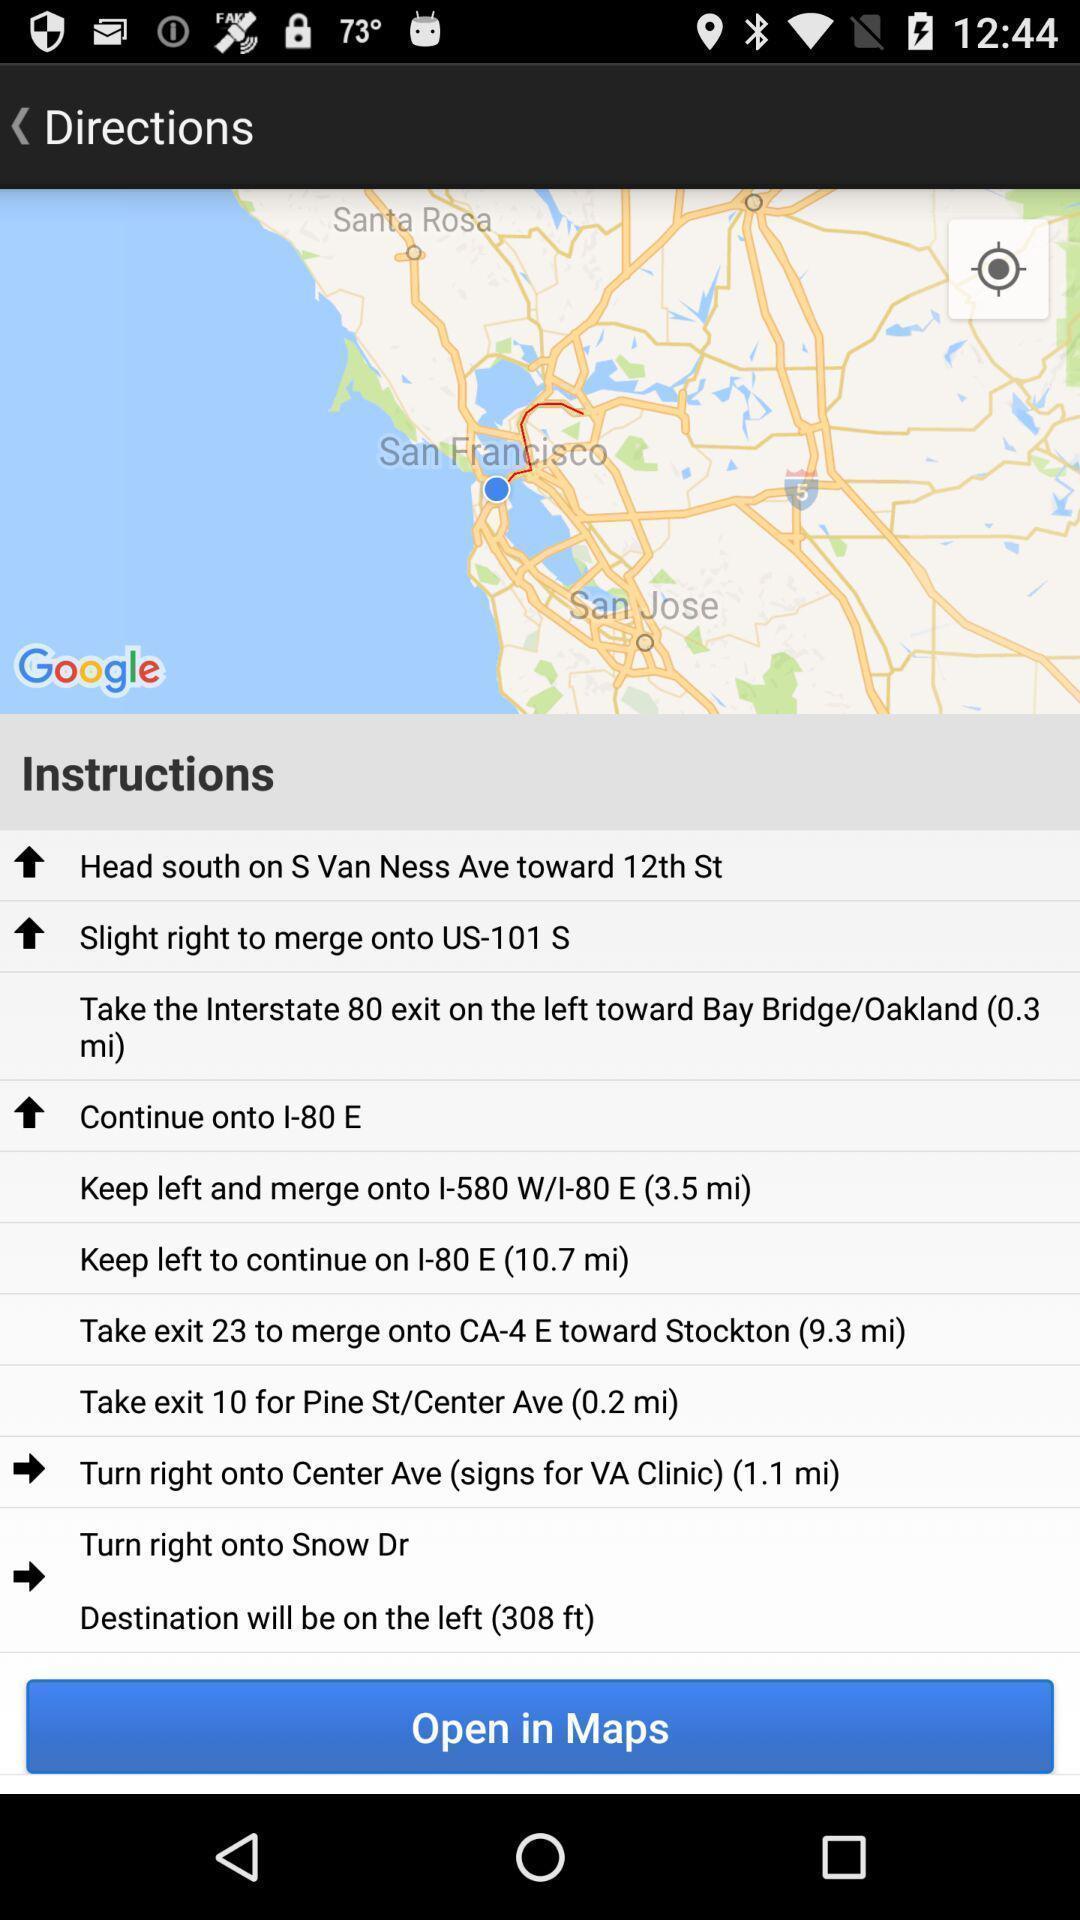What is the overall content of this screenshot? Various navigation instructions displayed of a map app. 